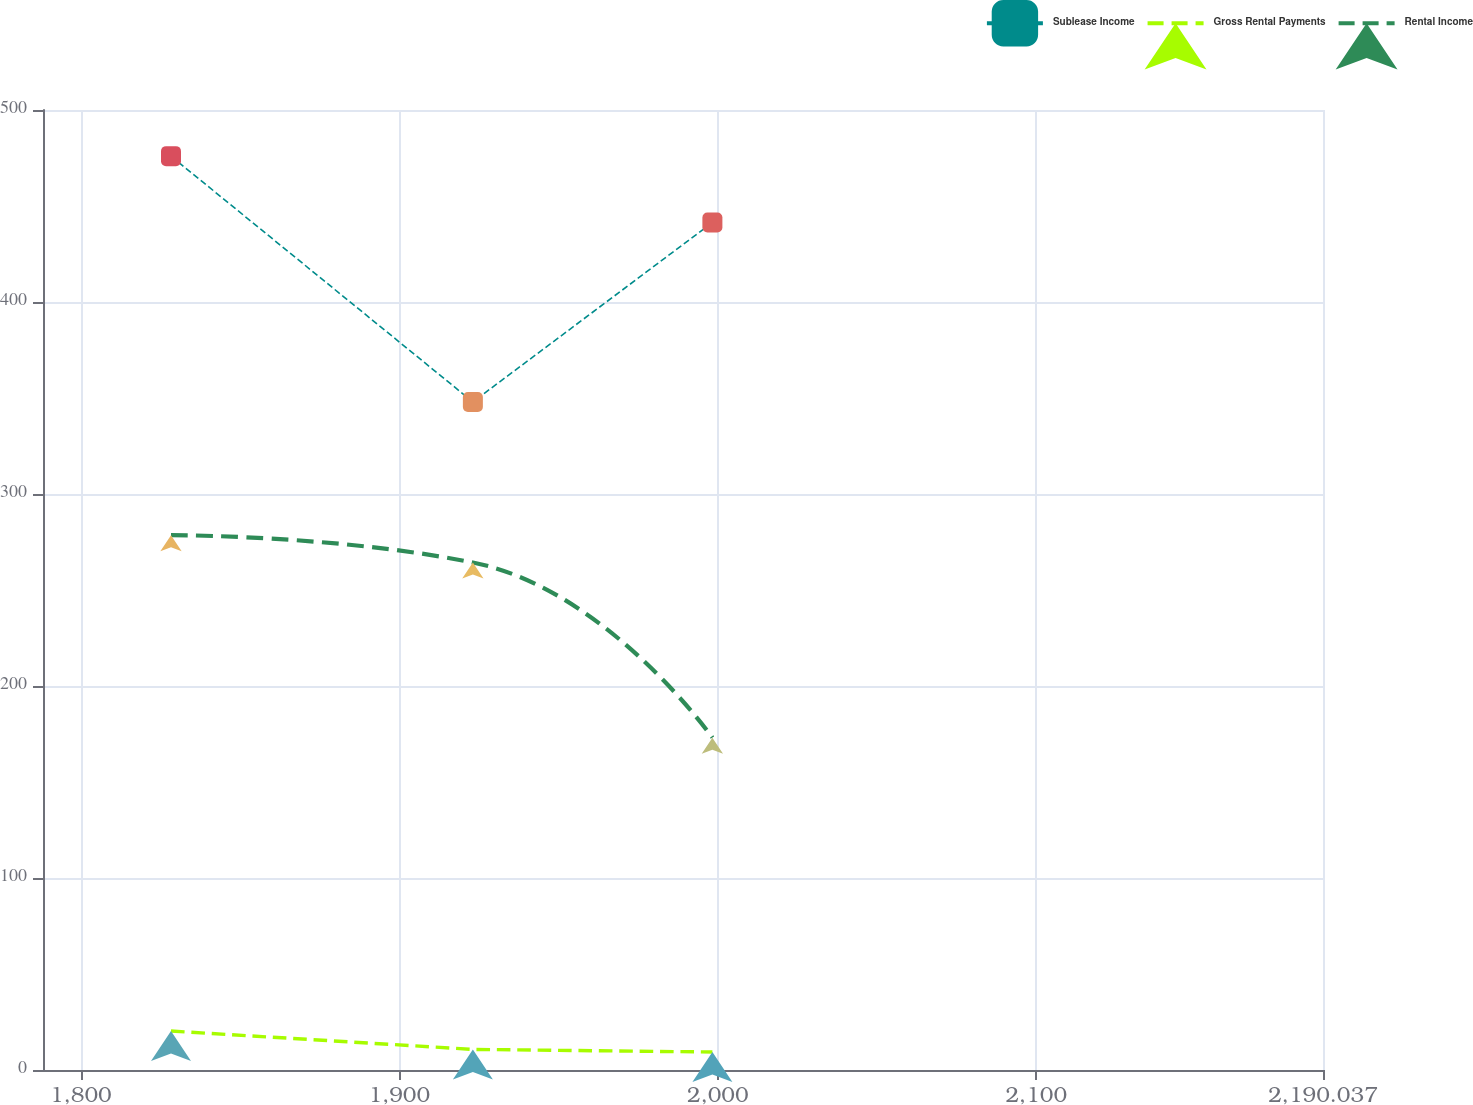<chart> <loc_0><loc_0><loc_500><loc_500><line_chart><ecel><fcel>Sublease Income<fcel>Gross Rental Payments<fcel>Rental Income<nl><fcel>1828.3<fcel>475.96<fcel>20.28<fcel>278.56<nl><fcel>1923.09<fcel>347.96<fcel>10.73<fcel>264.33<nl><fcel>1998.3<fcel>441.37<fcel>9.37<fcel>173.11<nl><fcel>2193.08<fcel>376.97<fcel>6.65<fcel>144.75<nl><fcel>2230.23<fcel>185.82<fcel>8.01<fcel>125.48<nl></chart> 